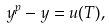Convert formula to latex. <formula><loc_0><loc_0><loc_500><loc_500>y ^ { p } - y = u ( T ) ,</formula> 